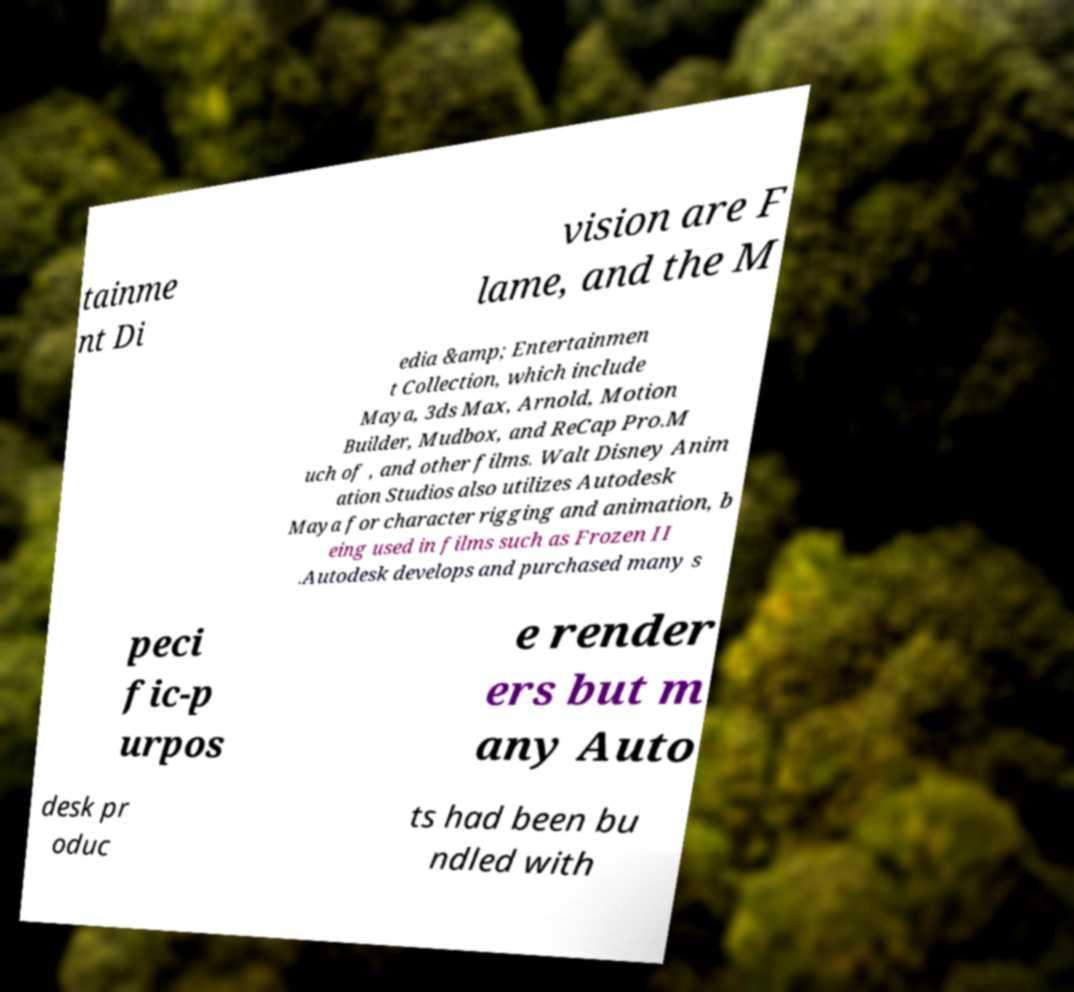Can you read and provide the text displayed in the image?This photo seems to have some interesting text. Can you extract and type it out for me? tainme nt Di vision are F lame, and the M edia &amp; Entertainmen t Collection, which include Maya, 3ds Max, Arnold, Motion Builder, Mudbox, and ReCap Pro.M uch of , and other films. Walt Disney Anim ation Studios also utilizes Autodesk Maya for character rigging and animation, b eing used in films such as Frozen II .Autodesk develops and purchased many s peci fic-p urpos e render ers but m any Auto desk pr oduc ts had been bu ndled with 